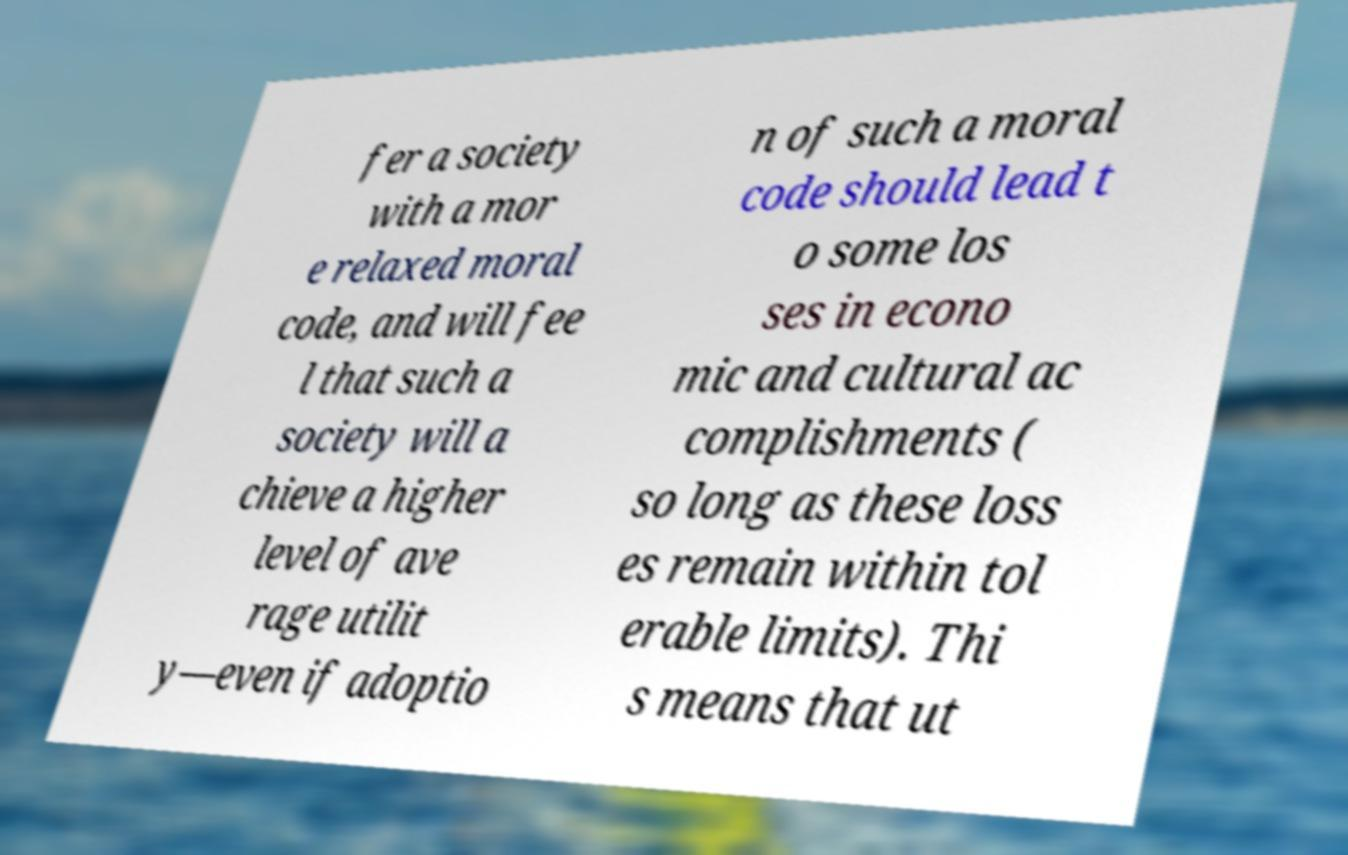What messages or text are displayed in this image? I need them in a readable, typed format. fer a society with a mor e relaxed moral code, and will fee l that such a society will a chieve a higher level of ave rage utilit y—even if adoptio n of such a moral code should lead t o some los ses in econo mic and cultural ac complishments ( so long as these loss es remain within tol erable limits). Thi s means that ut 